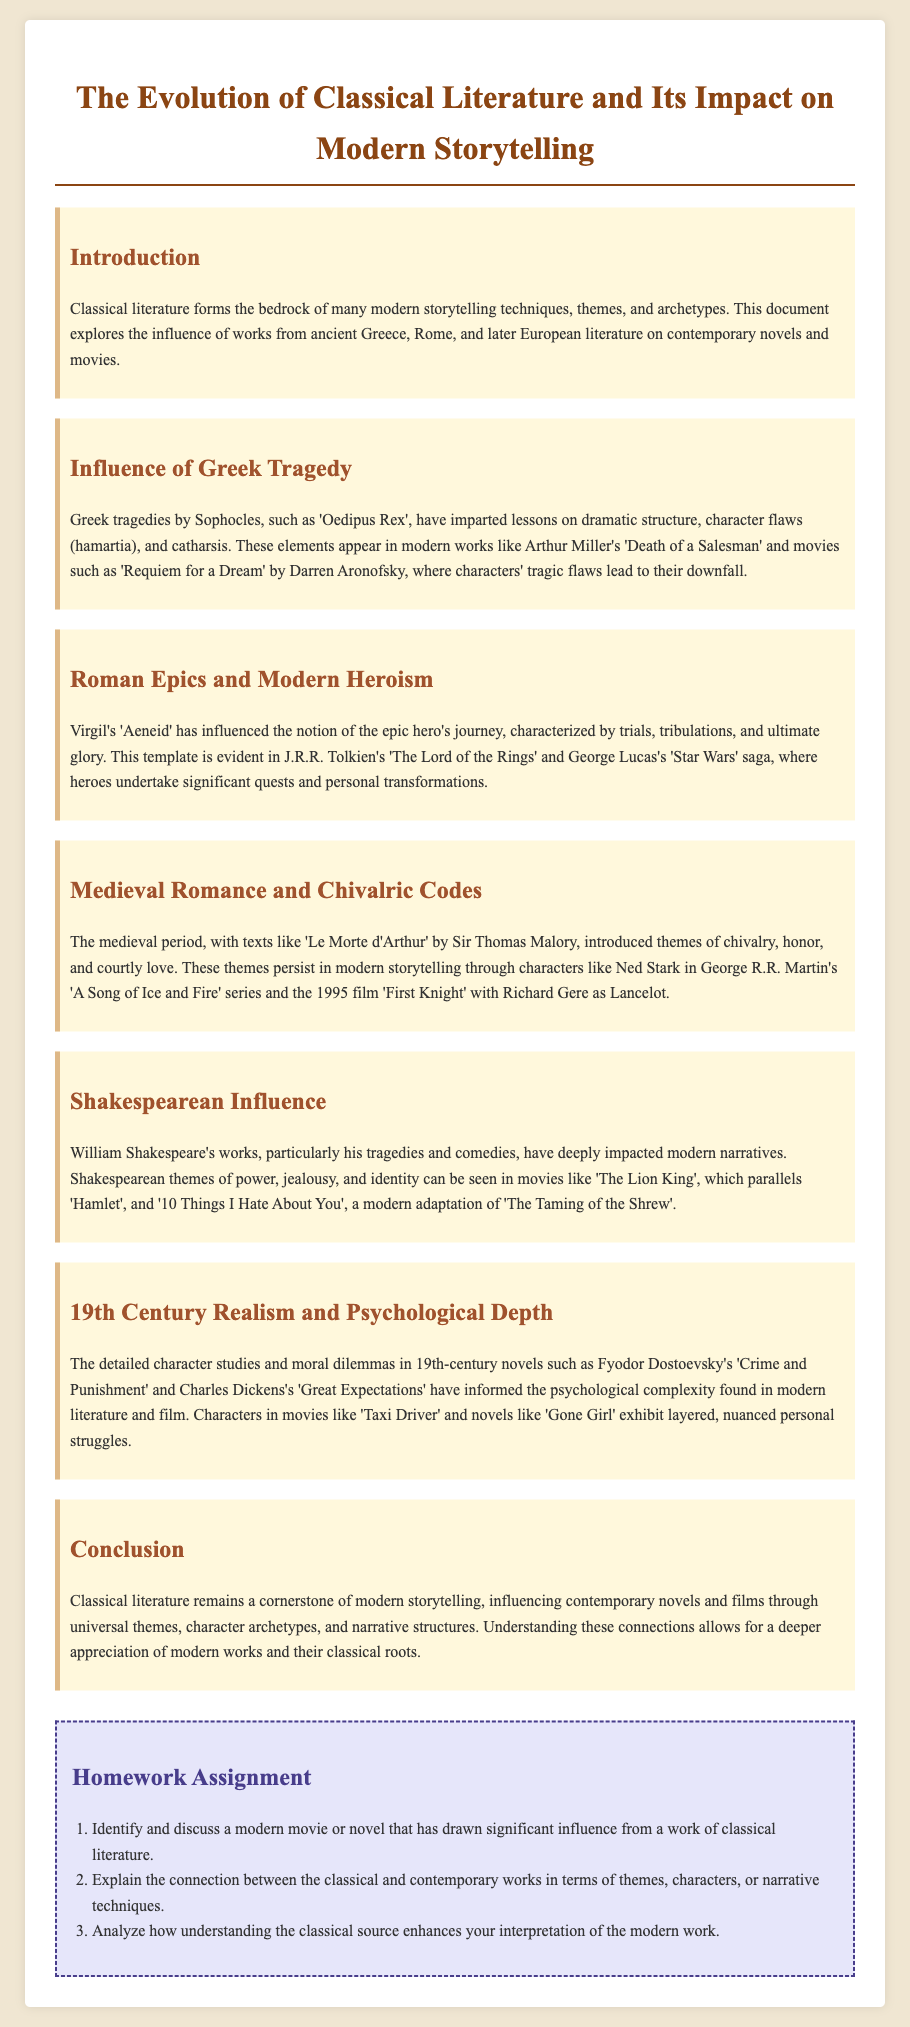What is the title of the document? The title of the document is listed prominently at the top of the rendered page.
Answer: The Evolution of Classical Literature and Its Impact on Modern Storytelling Who wrote 'Oedipus Rex'? The document attributes 'Oedipus Rex' to the playwright who is mentioned in the section about Greek Tragedy.
Answer: Sophocles Which novel is mentioned as influenced by the 'Aeneid'? The influence of the 'Aeneid' is connected to specific modern works in the section discussing Roman Epics.
Answer: The Lord of the Rings What genre of literature does 'Le Morte d'Arthur' belong to? The document identifies the work as a significant text from a specific literary period that it mentions.
Answer: Medieval Romance Which Shakespearean play is compared to 'The Lion King'? The document makes a direct comparison between modern storytelling and a classical play in the section about Shakespearean Influence.
Answer: Hamlet How many homework assignments are listed? The document outlines specific tasks under the Homework Assignment section, which indicates the number of assignments.
Answer: Three 